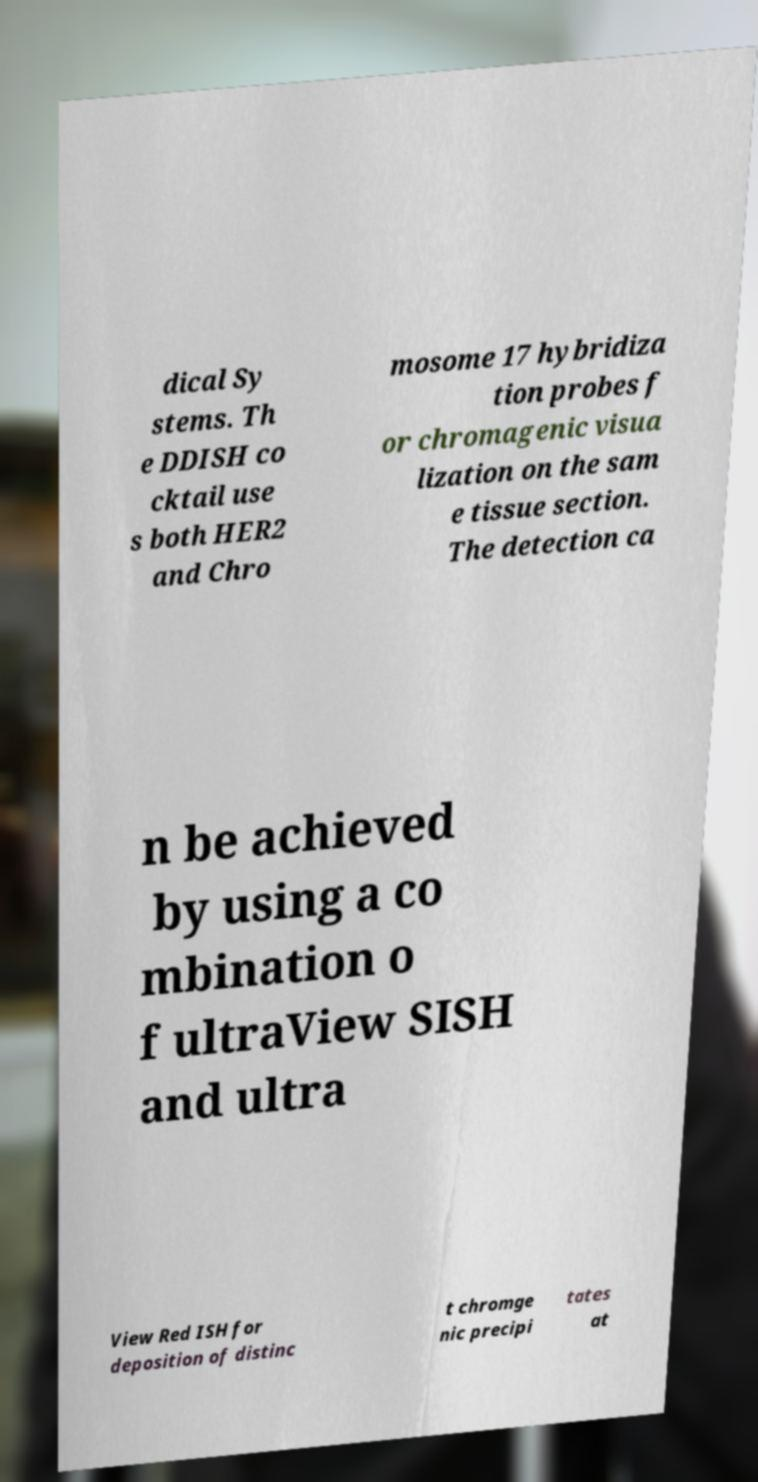There's text embedded in this image that I need extracted. Can you transcribe it verbatim? dical Sy stems. Th e DDISH co cktail use s both HER2 and Chro mosome 17 hybridiza tion probes f or chromagenic visua lization on the sam e tissue section. The detection ca n be achieved by using a co mbination o f ultraView SISH and ultra View Red ISH for deposition of distinc t chromge nic precipi tates at 